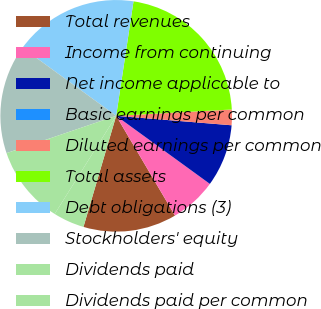Convert chart. <chart><loc_0><loc_0><loc_500><loc_500><pie_chart><fcel>Total revenues<fcel>Income from continuing<fcel>Net income applicable to<fcel>Basic earnings per common<fcel>Diluted earnings per common<fcel>Total assets<fcel>Debt obligations (3)<fcel>Stockholders' equity<fcel>Dividends paid<fcel>Dividends paid per common<nl><fcel>13.04%<fcel>6.52%<fcel>8.7%<fcel>0.0%<fcel>2.17%<fcel>21.74%<fcel>17.39%<fcel>15.22%<fcel>10.87%<fcel>4.35%<nl></chart> 